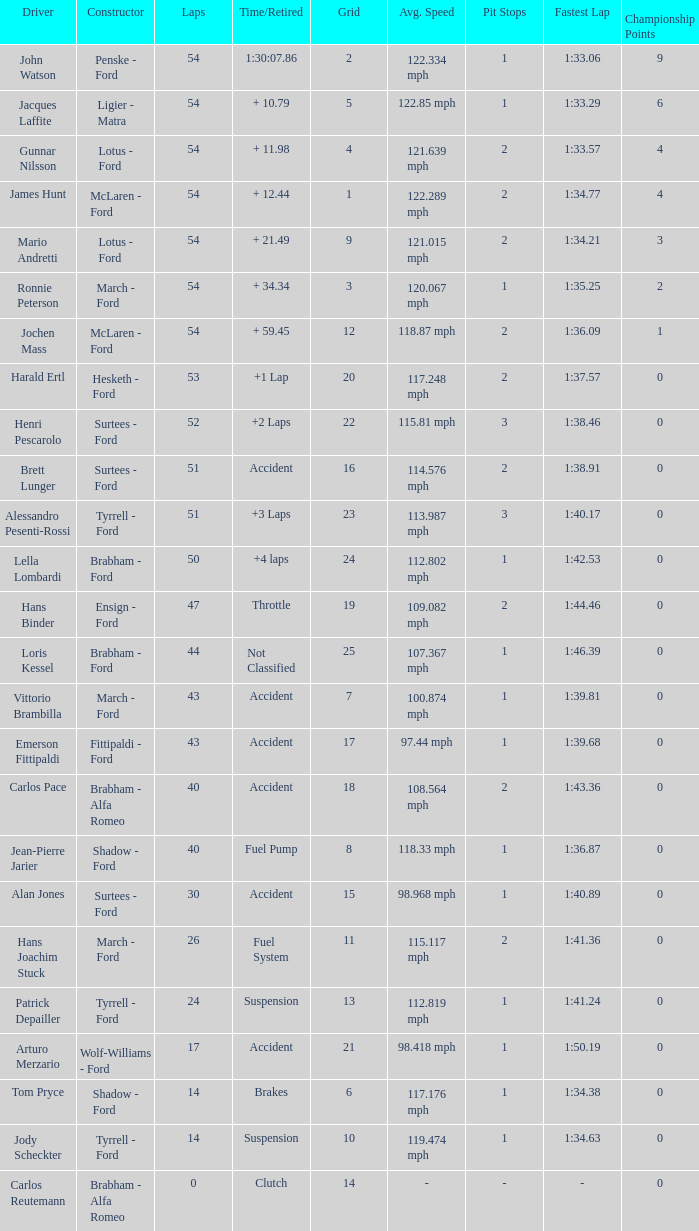How many laps did Emerson Fittipaldi do on a grid larger than 14, and when was the Time/Retired of accident? 1.0. 